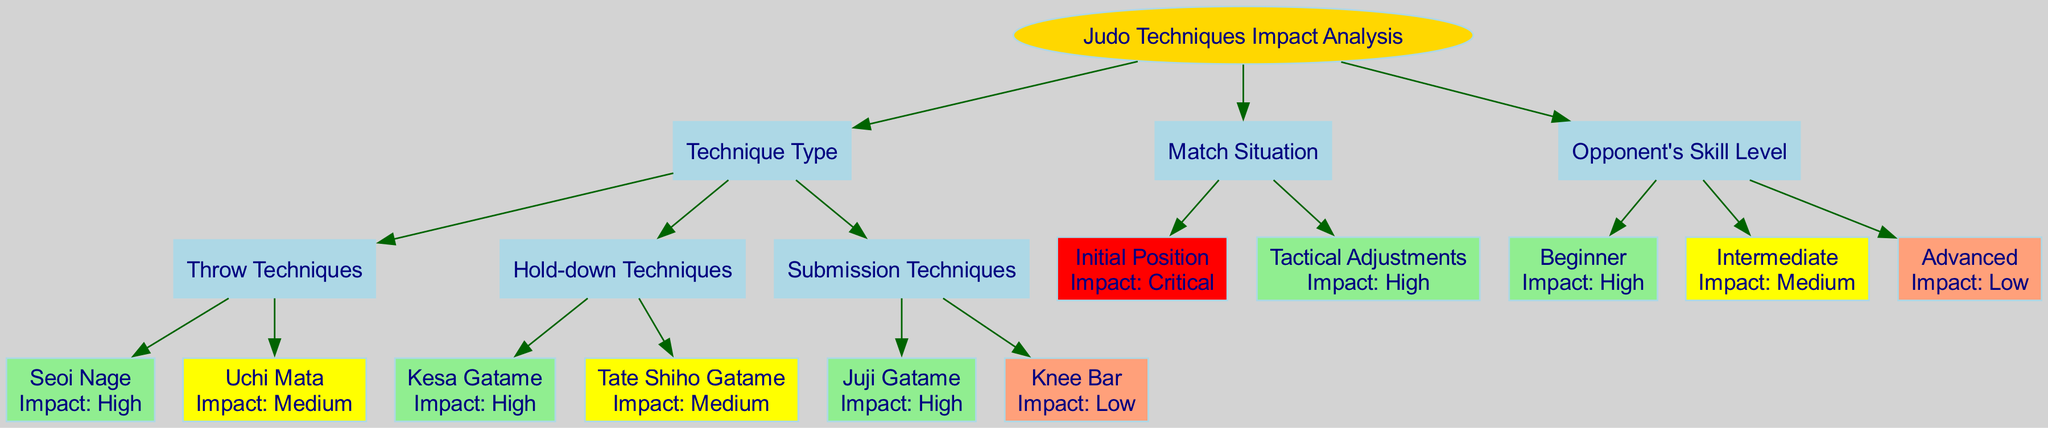What are the two main categories of Judo techniques in this diagram? The two main categories of Judo techniques identified in the diagram are "Technique Type" and "Match Situation." These categories are represented as the first-level nodes under the main root node, "Judo Techniques Impact Analysis."
Answer: Technique Type, Match Situation Which technique has the highest impact under Throw Techniques? The technique with the highest impact under Throw Techniques is "Seoi Nage." This is indicated by its label in the diagram, which notes its high impact status.
Answer: Seoi Nage How many techniques are listed under Submission Techniques? There are two techniques listed under Submission Techniques. The diagram shows "Juji Gatame" and "Knee Bar" as the children nodes of the "Submission Techniques" parent node.
Answer: 2 What is the impact level of "Tactical Adjustments"? The impact level of "Tactical Adjustments" is "High." This is noted in the diagram as the impact assigned to the "Tactical Adjustments" node under the "Match Situation" category.
Answer: High When facing an Advanced opponent, what is the expected impact of Judo techniques? The expected impact of Judo techniques when facing an Advanced opponent is "Low." This is derived from the impact level associated with the "Advanced" node in the "Opponent's Skill Level" section of the diagram.
Answer: Low Which technique under Hold-down Techniques has a medium impact? The technique under Hold-down Techniques that has a medium impact is "Tate Shiho Gatame." This is shown in the diagram where its impact is distinctly labeled as medium.
Answer: Tate Shiho Gatame What is the relationship between the "Initial Position" and "Match Situation"? The relationship is that "Initial Position" is a child node under the "Match Situation" parent node. This means that "Initial Position" is one of the subcategories used to analyze match situations.
Answer: Child node What is the overall impact of using Submission Techniques against a Beginner opponent? The overall impact when using Submission Techniques against a Beginner opponent is "High." This combines the high impact of "Juji Gatame" (a Submission Technique) with the high impact assessed for a Beginner opponent in the overall analysis.
Answer: High 